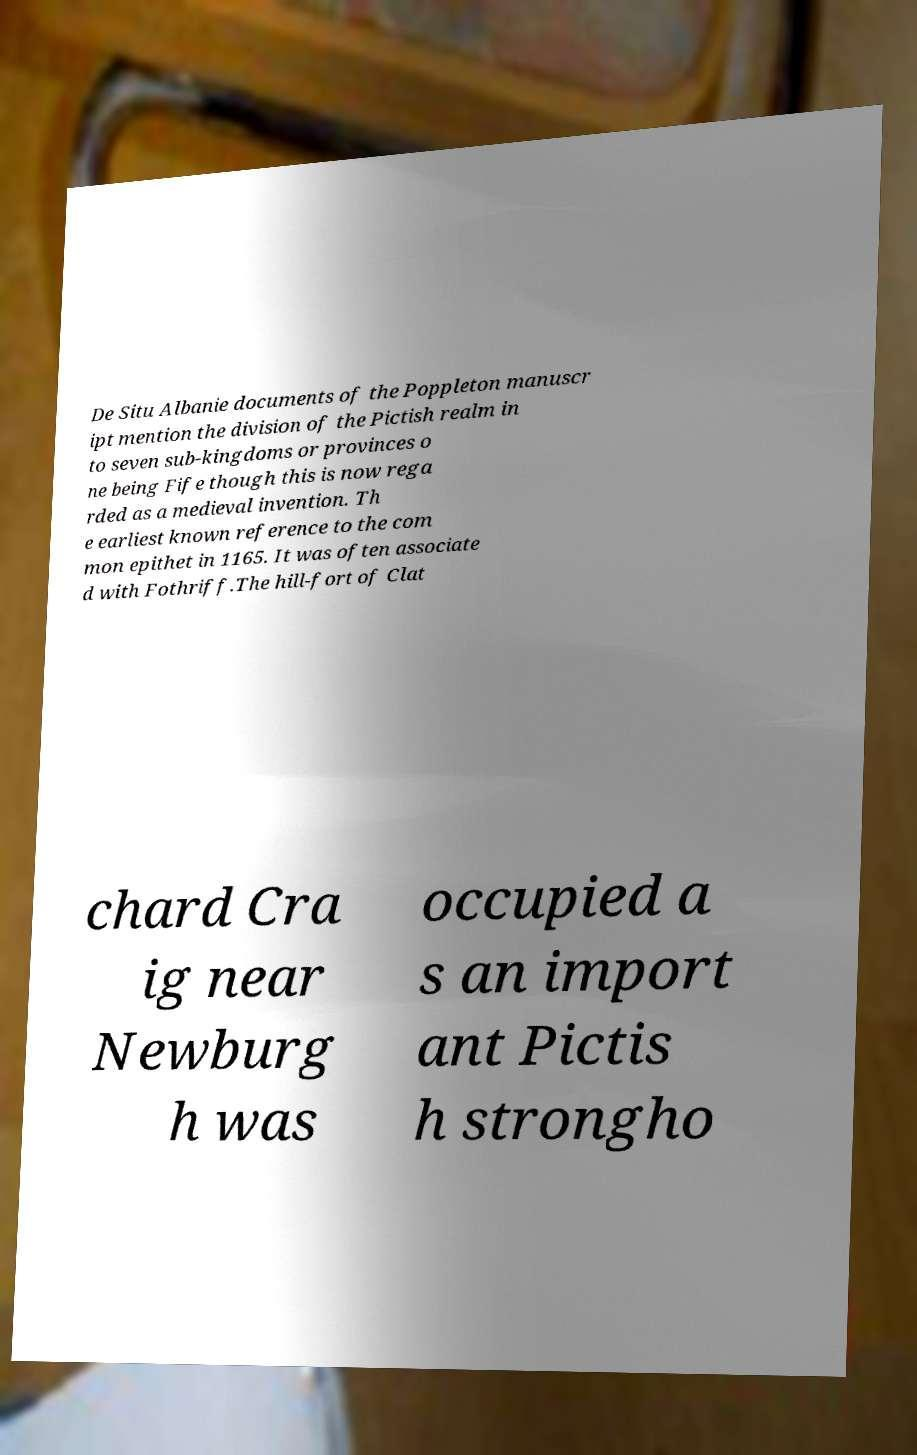Could you assist in decoding the text presented in this image and type it out clearly? De Situ Albanie documents of the Poppleton manuscr ipt mention the division of the Pictish realm in to seven sub-kingdoms or provinces o ne being Fife though this is now rega rded as a medieval invention. Th e earliest known reference to the com mon epithet in 1165. It was often associate d with Fothriff.The hill-fort of Clat chard Cra ig near Newburg h was occupied a s an import ant Pictis h strongho 